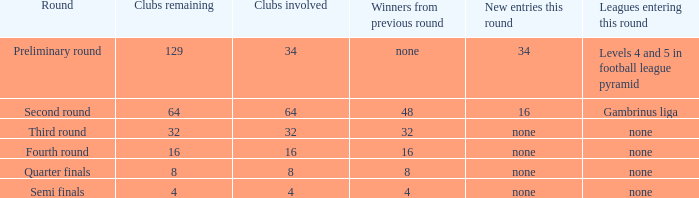Name the least clubs involved for leagues being none for semi finals 4.0. 